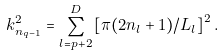<formula> <loc_0><loc_0><loc_500><loc_500>k _ { n _ { q - 1 } } ^ { 2 } = \sum _ { l = p + 2 } ^ { D } \left [ \pi ( 2 n _ { l } + 1 ) / L _ { l } \right ] ^ { 2 } .</formula> 